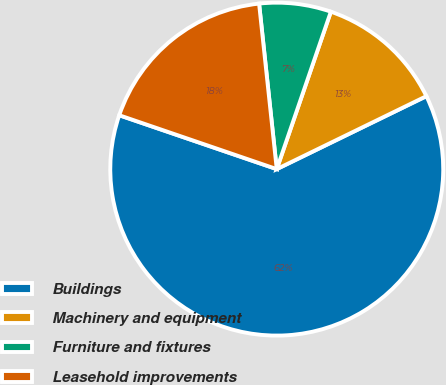Convert chart to OTSL. <chart><loc_0><loc_0><loc_500><loc_500><pie_chart><fcel>Buildings<fcel>Machinery and equipment<fcel>Furniture and fixtures<fcel>Leasehold improvements<nl><fcel>62.46%<fcel>12.51%<fcel>6.96%<fcel>18.06%<nl></chart> 